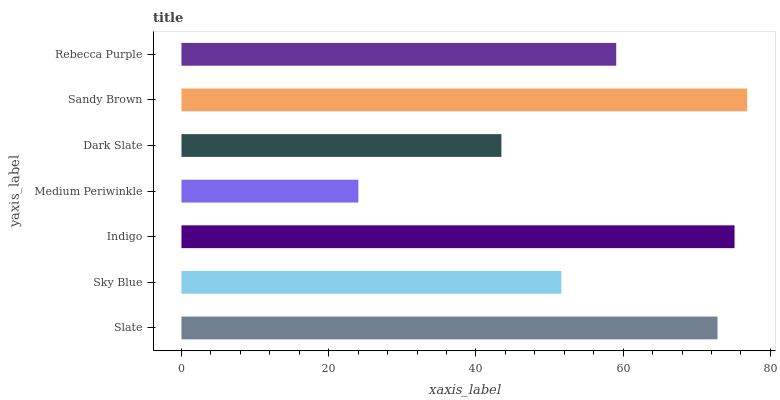Is Medium Periwinkle the minimum?
Answer yes or no. Yes. Is Sandy Brown the maximum?
Answer yes or no. Yes. Is Sky Blue the minimum?
Answer yes or no. No. Is Sky Blue the maximum?
Answer yes or no. No. Is Slate greater than Sky Blue?
Answer yes or no. Yes. Is Sky Blue less than Slate?
Answer yes or no. Yes. Is Sky Blue greater than Slate?
Answer yes or no. No. Is Slate less than Sky Blue?
Answer yes or no. No. Is Rebecca Purple the high median?
Answer yes or no. Yes. Is Rebecca Purple the low median?
Answer yes or no. Yes. Is Slate the high median?
Answer yes or no. No. Is Indigo the low median?
Answer yes or no. No. 